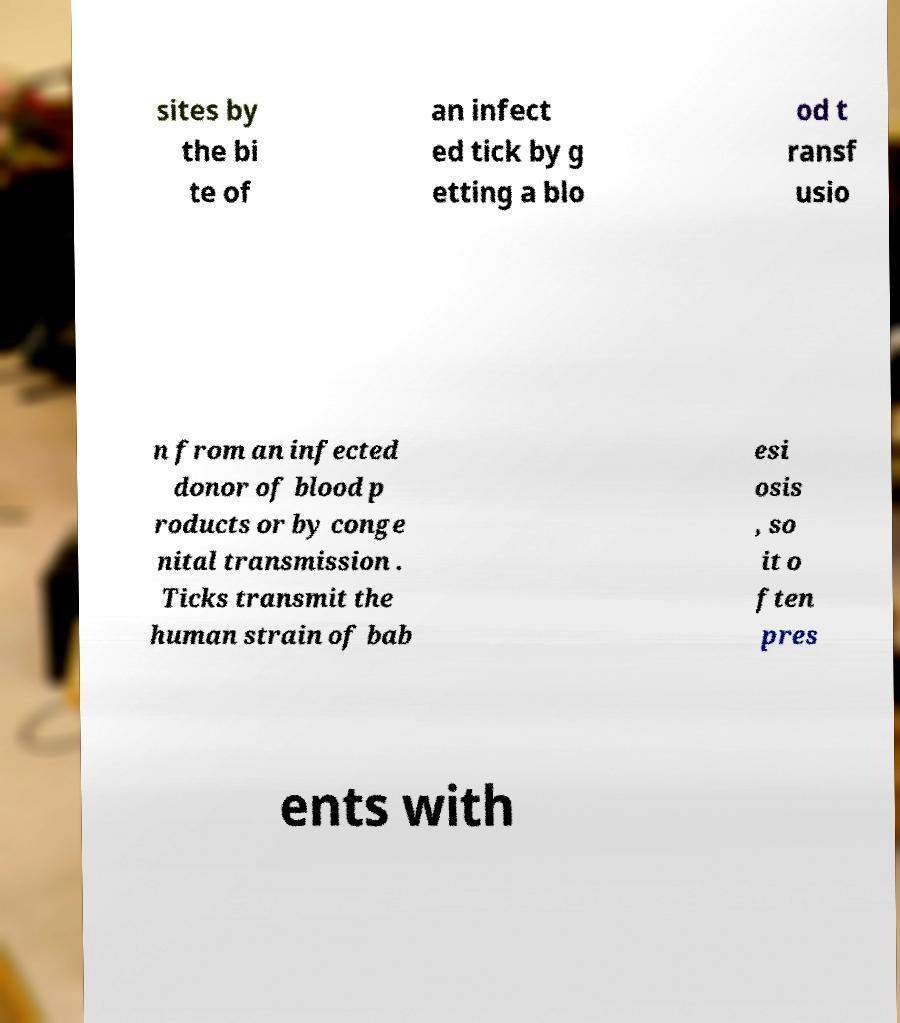Can you accurately transcribe the text from the provided image for me? sites by the bi te of an infect ed tick by g etting a blo od t ransf usio n from an infected donor of blood p roducts or by conge nital transmission . Ticks transmit the human strain of bab esi osis , so it o ften pres ents with 